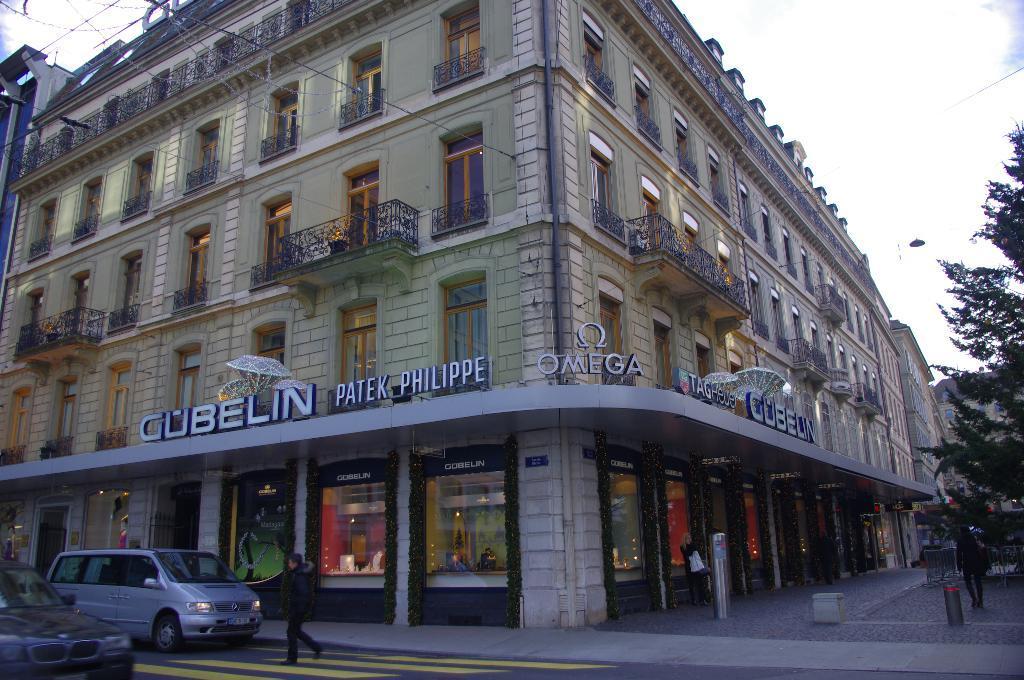Can you describe this image briefly? In this image I can see few vehicles and I can see two persons walking. In the background I can see few stalls and the building and I can also see few glass windows, trees in green color and the sky is in white color. 